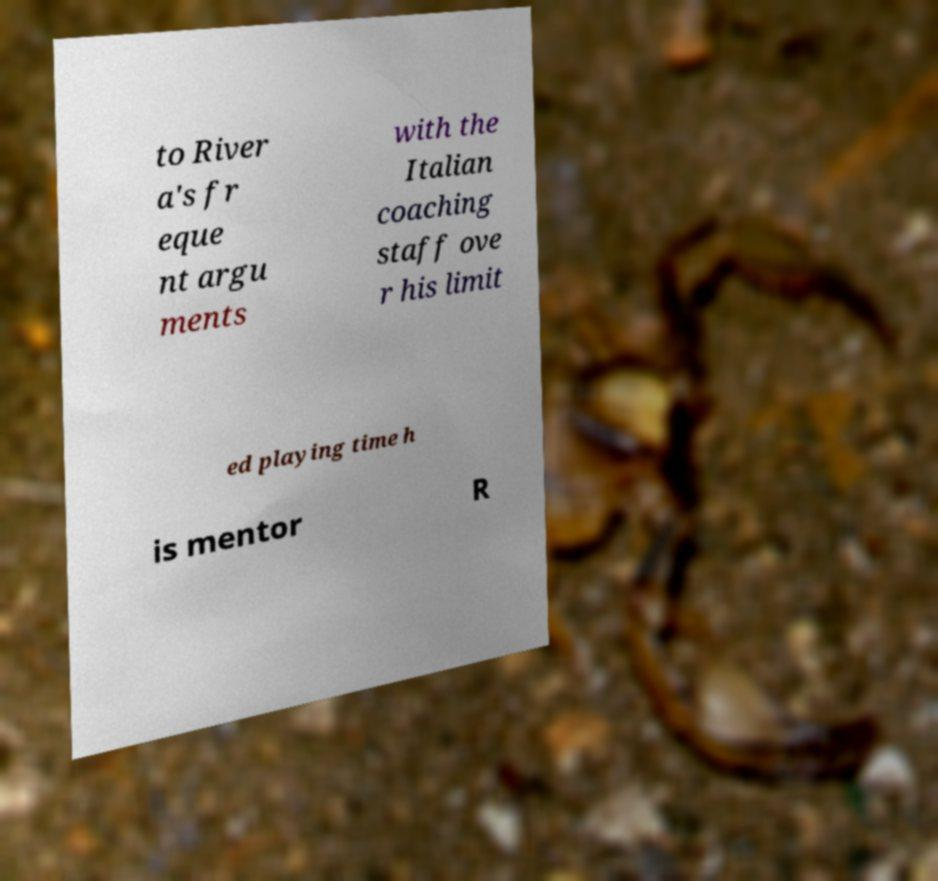Please read and relay the text visible in this image. What does it say? to River a's fr eque nt argu ments with the Italian coaching staff ove r his limit ed playing time h is mentor R 